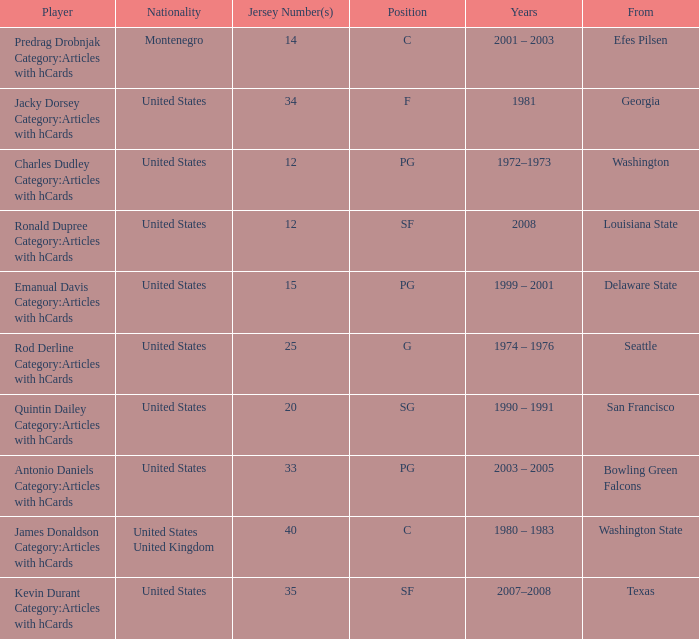What is the least jersey number of a player from louisiana state? 12.0. 